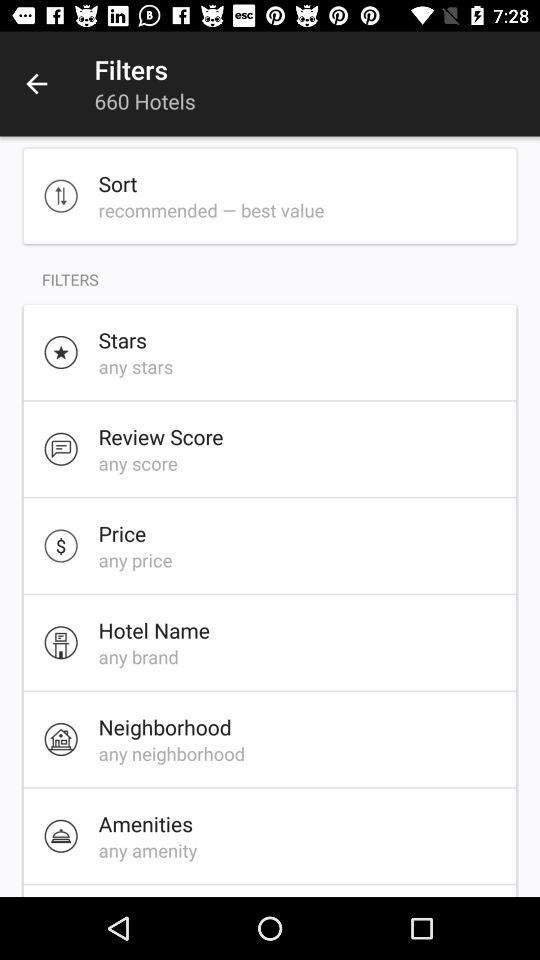How many hotels are there? There are 660 hotels. 